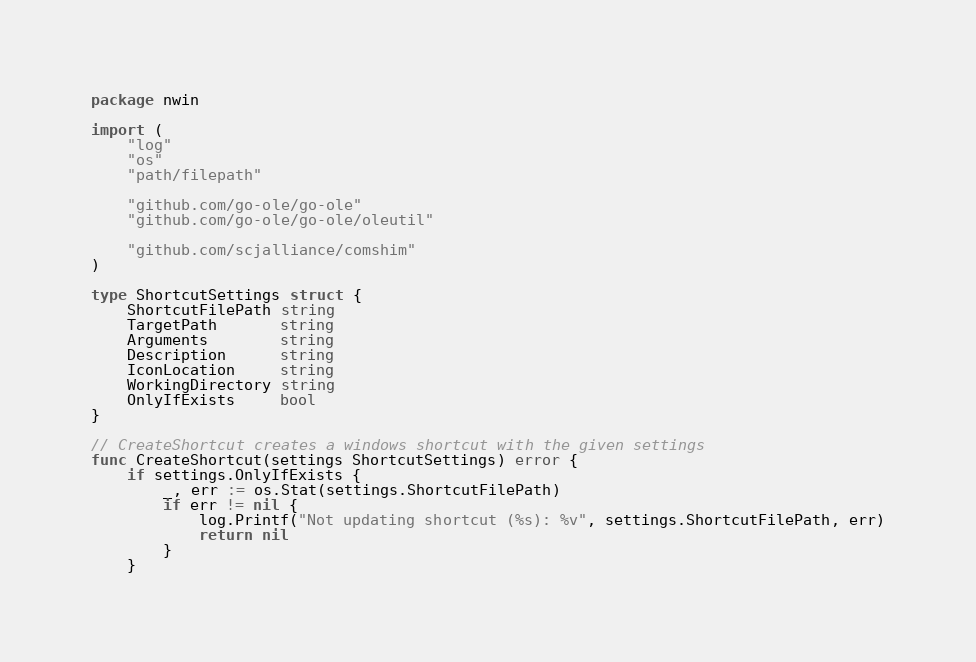<code> <loc_0><loc_0><loc_500><loc_500><_Go_>package nwin

import (
	"log"
	"os"
	"path/filepath"

	"github.com/go-ole/go-ole"
	"github.com/go-ole/go-ole/oleutil"

	"github.com/scjalliance/comshim"
)

type ShortcutSettings struct {
	ShortcutFilePath string
	TargetPath       string
	Arguments        string
	Description      string
	IconLocation     string
	WorkingDirectory string
	OnlyIfExists     bool
}

// CreateShortcut creates a windows shortcut with the given settings
func CreateShortcut(settings ShortcutSettings) error {
	if settings.OnlyIfExists {
		_, err := os.Stat(settings.ShortcutFilePath)
		if err != nil {
			log.Printf("Not updating shortcut (%s): %v", settings.ShortcutFilePath, err)
			return nil
		}
	}
</code> 